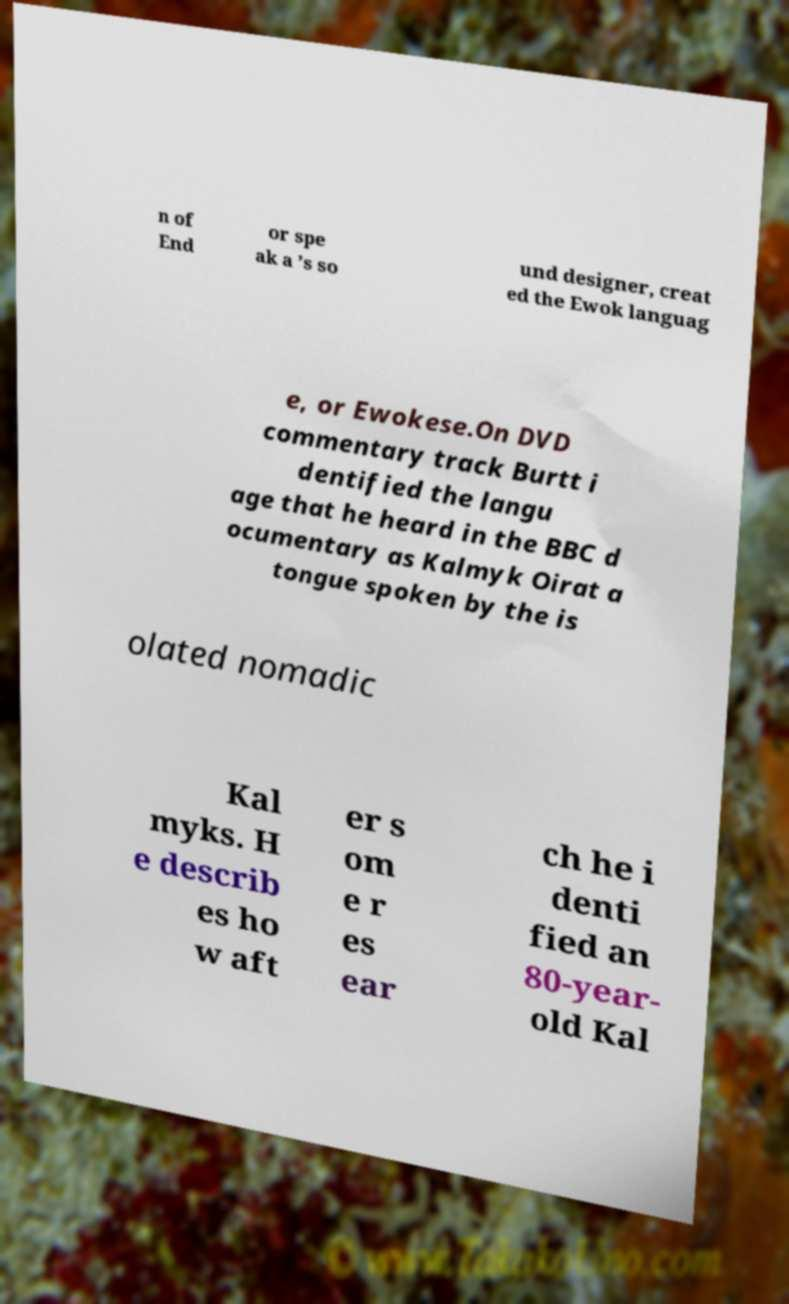What messages or text are displayed in this image? I need them in a readable, typed format. n of End or spe ak a ’s so und designer, creat ed the Ewok languag e, or Ewokese.On DVD commentary track Burtt i dentified the langu age that he heard in the BBC d ocumentary as Kalmyk Oirat a tongue spoken by the is olated nomadic Kal myks. H e describ es ho w aft er s om e r es ear ch he i denti fied an 80-year- old Kal 